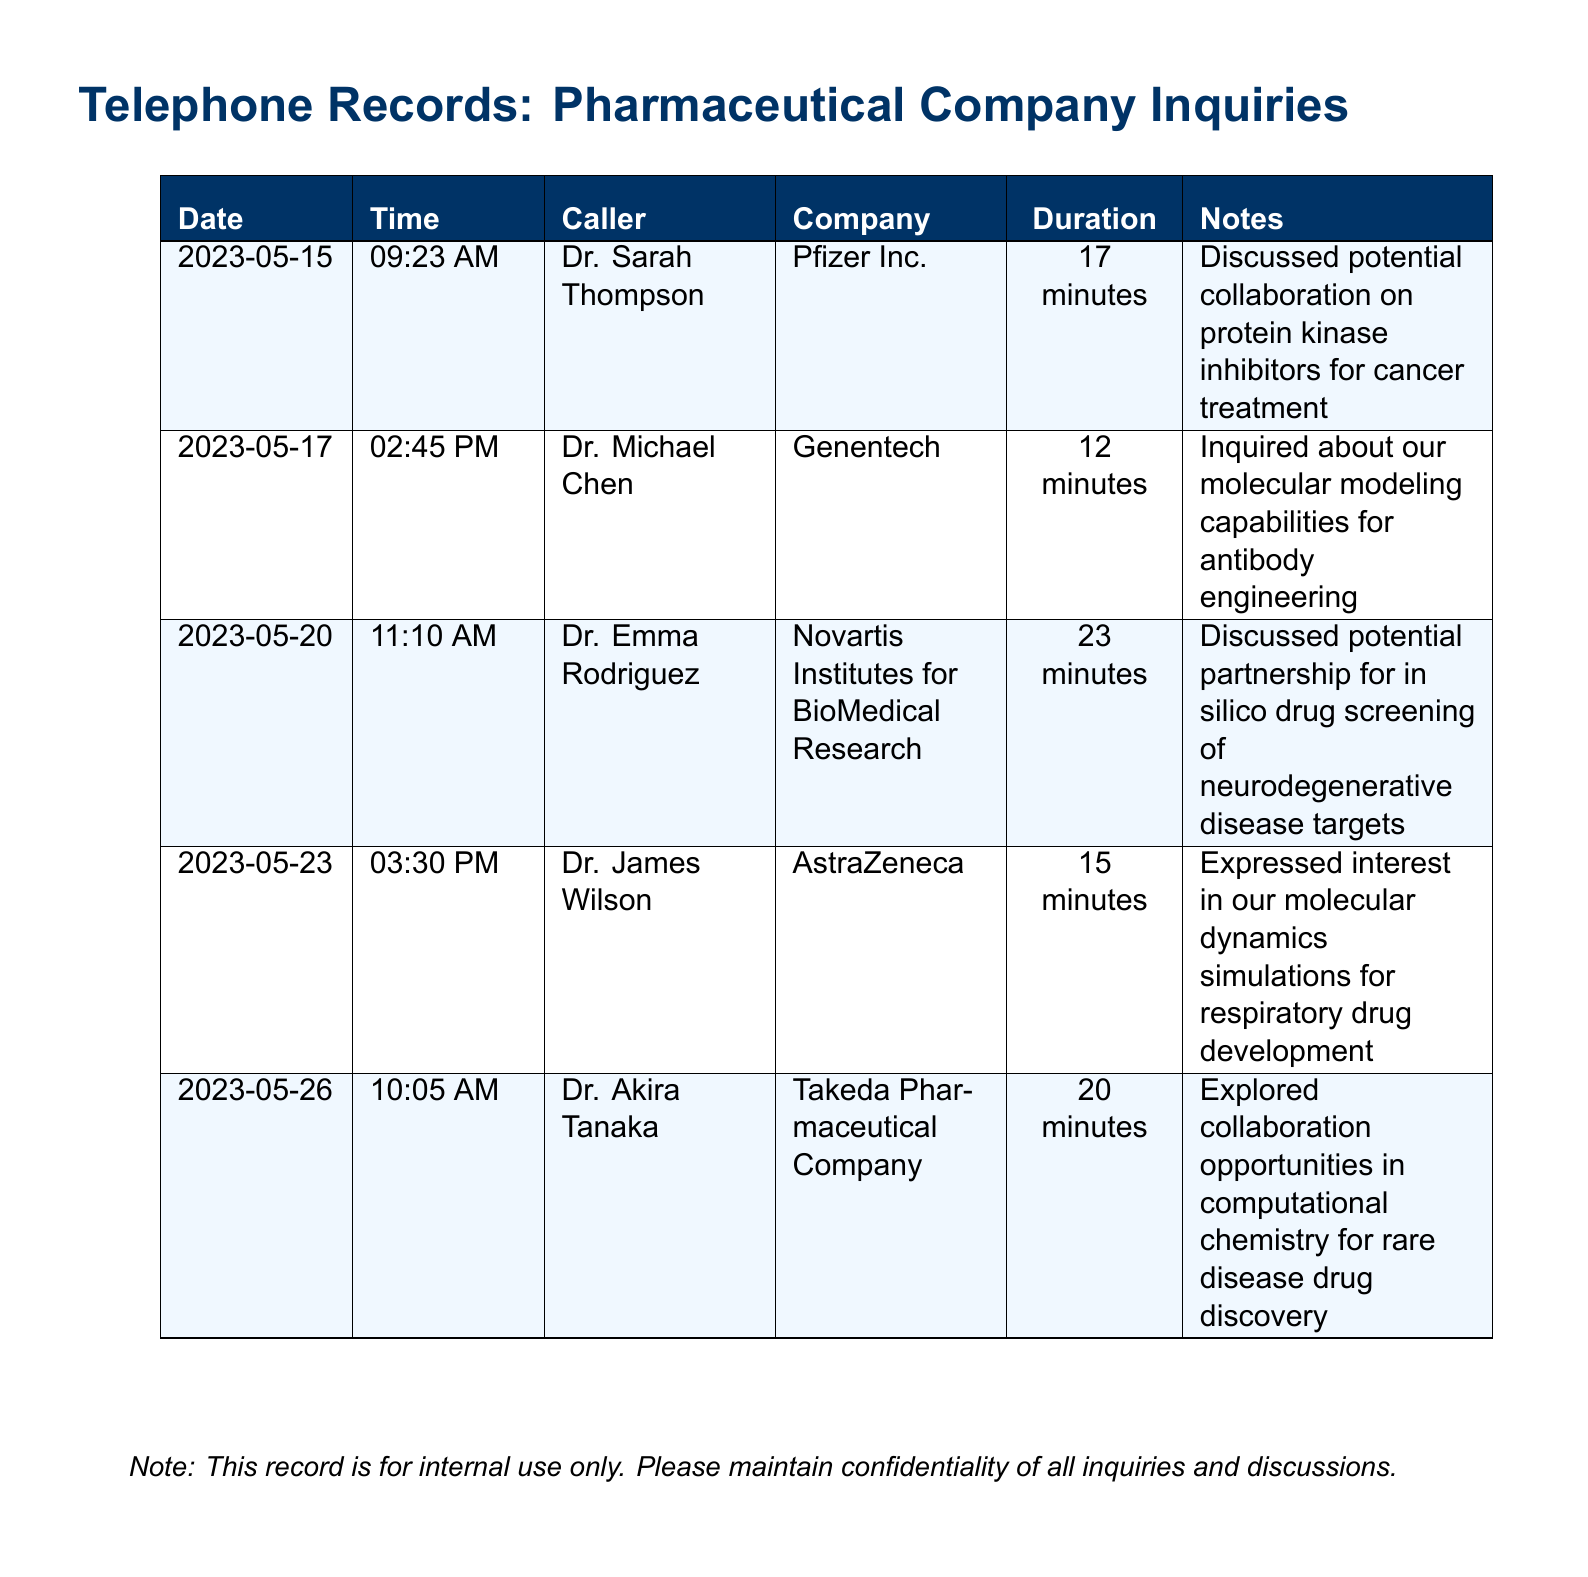What is the date of the first call? The first call is listed on May 15, 2023.
Answer: 2023-05-15 Who called from AstraZeneca? The document states that Dr. James Wilson was the caller from AstraZeneca.
Answer: Dr. James Wilson How long did the call with Genentech last? The duration of the call with Genentech was 12 minutes.
Answer: 12 minutes What specific topic was discussed with Pfizer Inc.? The discussion with Pfizer Inc. focused on collaboration for protein kinase inhibitors.
Answer: Protein kinase inhibitors Which company expressed interest in molecular dynamics simulations? AstraZeneca expressed interest in molecular dynamics simulations.
Answer: AstraZeneca What was the call duration for Novartis Institutes for BioMedical Research? The call lasted for 23 minutes.
Answer: 23 minutes Who inquired about antibody engineering? Dr. Michael Chen inquired about antibody engineering.
Answer: Dr. Michael Chen Which pharmaceutical company was associated with Dr. Akira Tanaka? Dr. Akira Tanaka is associated with Takeda Pharmaceutical Company.
Answer: Takeda Pharmaceutical Company How many calls are recorded in total? The document lists a total of five calls.
Answer: 5 